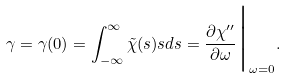Convert formula to latex. <formula><loc_0><loc_0><loc_500><loc_500>\gamma = \gamma ( 0 ) = \int _ { - \infty } ^ { \infty } \tilde { \chi } ( s ) s d s = \frac { \partial \chi ^ { \prime \prime } } { \partial \omega } \Big | _ { \omega = 0 } .</formula> 